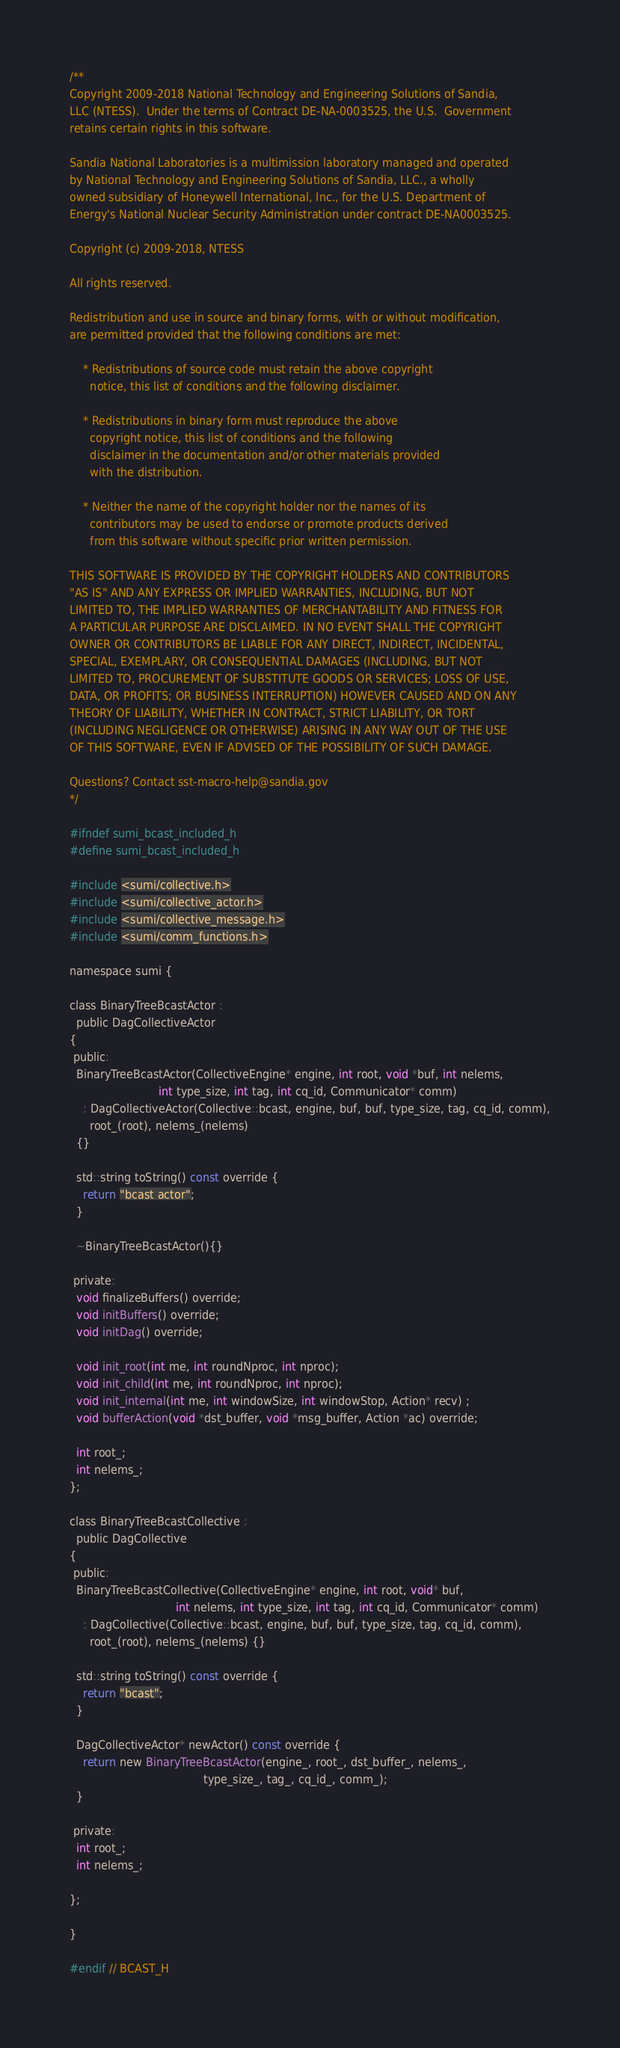<code> <loc_0><loc_0><loc_500><loc_500><_C_>/**
Copyright 2009-2018 National Technology and Engineering Solutions of Sandia, 
LLC (NTESS).  Under the terms of Contract DE-NA-0003525, the U.S.  Government 
retains certain rights in this software.

Sandia National Laboratories is a multimission laboratory managed and operated
by National Technology and Engineering Solutions of Sandia, LLC., a wholly 
owned subsidiary of Honeywell International, Inc., for the U.S. Department of 
Energy's National Nuclear Security Administration under contract DE-NA0003525.

Copyright (c) 2009-2018, NTESS

All rights reserved.

Redistribution and use in source and binary forms, with or without modification, 
are permitted provided that the following conditions are met:

    * Redistributions of source code must retain the above copyright
      notice, this list of conditions and the following disclaimer.

    * Redistributions in binary form must reproduce the above
      copyright notice, this list of conditions and the following
      disclaimer in the documentation and/or other materials provided
      with the distribution.

    * Neither the name of the copyright holder nor the names of its
      contributors may be used to endorse or promote products derived
      from this software without specific prior written permission.

THIS SOFTWARE IS PROVIDED BY THE COPYRIGHT HOLDERS AND CONTRIBUTORS
"AS IS" AND ANY EXPRESS OR IMPLIED WARRANTIES, INCLUDING, BUT NOT
LIMITED TO, THE IMPLIED WARRANTIES OF MERCHANTABILITY AND FITNESS FOR
A PARTICULAR PURPOSE ARE DISCLAIMED. IN NO EVENT SHALL THE COPYRIGHT
OWNER OR CONTRIBUTORS BE LIABLE FOR ANY DIRECT, INDIRECT, INCIDENTAL,
SPECIAL, EXEMPLARY, OR CONSEQUENTIAL DAMAGES (INCLUDING, BUT NOT
LIMITED TO, PROCUREMENT OF SUBSTITUTE GOODS OR SERVICES; LOSS OF USE,
DATA, OR PROFITS; OR BUSINESS INTERRUPTION) HOWEVER CAUSED AND ON ANY
THEORY OF LIABILITY, WHETHER IN CONTRACT, STRICT LIABILITY, OR TORT
(INCLUDING NEGLIGENCE OR OTHERWISE) ARISING IN ANY WAY OUT OF THE USE
OF THIS SOFTWARE, EVEN IF ADVISED OF THE POSSIBILITY OF SUCH DAMAGE.

Questions? Contact sst-macro-help@sandia.gov
*/

#ifndef sumi_bcast_included_h
#define sumi_bcast_included_h

#include <sumi/collective.h>
#include <sumi/collective_actor.h>
#include <sumi/collective_message.h>
#include <sumi/comm_functions.h>

namespace sumi {

class BinaryTreeBcastActor :
  public DagCollectiveActor
{
 public:
  BinaryTreeBcastActor(CollectiveEngine* engine, int root, void *buf, int nelems,
                          int type_size, int tag, int cq_id, Communicator* comm)
    : DagCollectiveActor(Collective::bcast, engine, buf, buf, type_size, tag, cq_id, comm),
      root_(root), nelems_(nelems)
  {}

  std::string toString() const override {
    return "bcast actor";
  }

  ~BinaryTreeBcastActor(){}

 private:
  void finalizeBuffers() override;
  void initBuffers() override;
  void initDag() override;

  void init_root(int me, int roundNproc, int nproc);
  void init_child(int me, int roundNproc, int nproc);
  void init_internal(int me, int windowSize, int windowStop, Action* recv) ;
  void bufferAction(void *dst_buffer, void *msg_buffer, Action *ac) override;

  int root_;
  int nelems_;
};

class BinaryTreeBcastCollective :
  public DagCollective
{
 public:
  BinaryTreeBcastCollective(CollectiveEngine* engine, int root, void* buf,
                               int nelems, int type_size, int tag, int cq_id, Communicator* comm)
    : DagCollective(Collective::bcast, engine, buf, buf, type_size, tag, cq_id, comm),
      root_(root), nelems_(nelems) {}

  std::string toString() const override {
    return "bcast";
  }

  DagCollectiveActor* newActor() const override {
    return new BinaryTreeBcastActor(engine_, root_, dst_buffer_, nelems_,
                                       type_size_, tag_, cq_id_, comm_);
  }

 private:
  int root_;
  int nelems_;

};

}

#endif // BCAST_H
</code> 